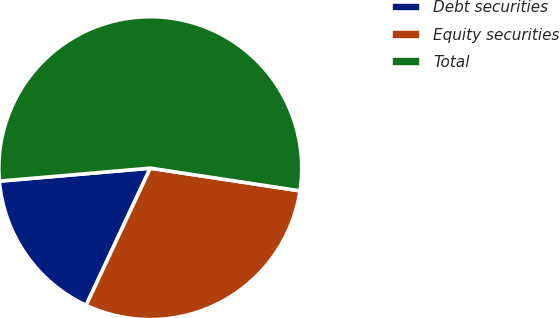<chart> <loc_0><loc_0><loc_500><loc_500><pie_chart><fcel>Debt securities<fcel>Equity securities<fcel>Total<nl><fcel>16.67%<fcel>29.57%<fcel>53.76%<nl></chart> 